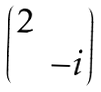Convert formula to latex. <formula><loc_0><loc_0><loc_500><loc_500>\begin{pmatrix} 2 \\ & - i \end{pmatrix}</formula> 